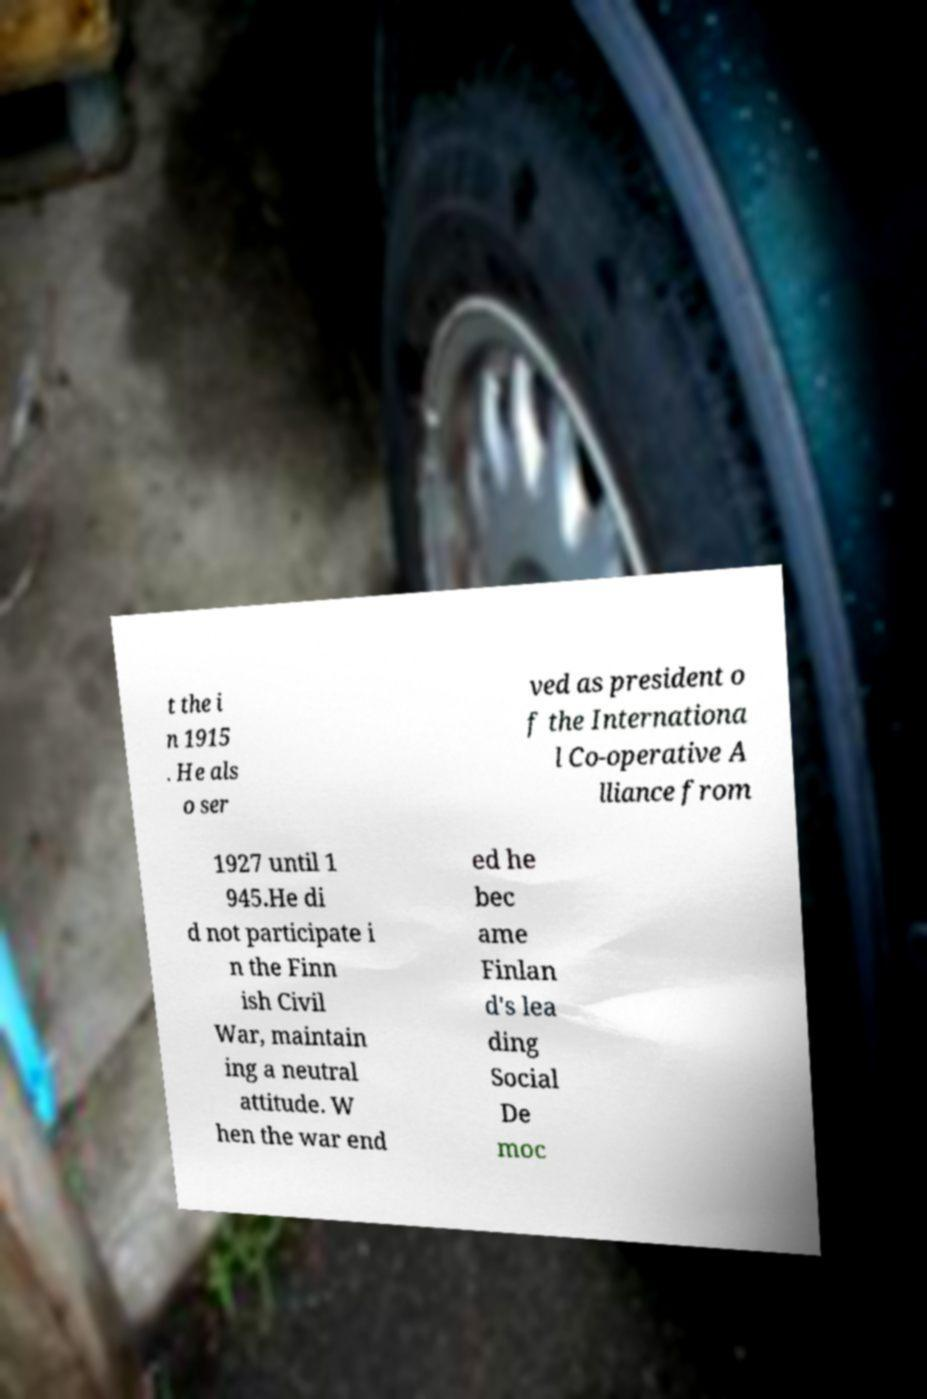What messages or text are displayed in this image? I need them in a readable, typed format. t the i n 1915 . He als o ser ved as president o f the Internationa l Co-operative A lliance from 1927 until 1 945.He di d not participate i n the Finn ish Civil War, maintain ing a neutral attitude. W hen the war end ed he bec ame Finlan d's lea ding Social De moc 